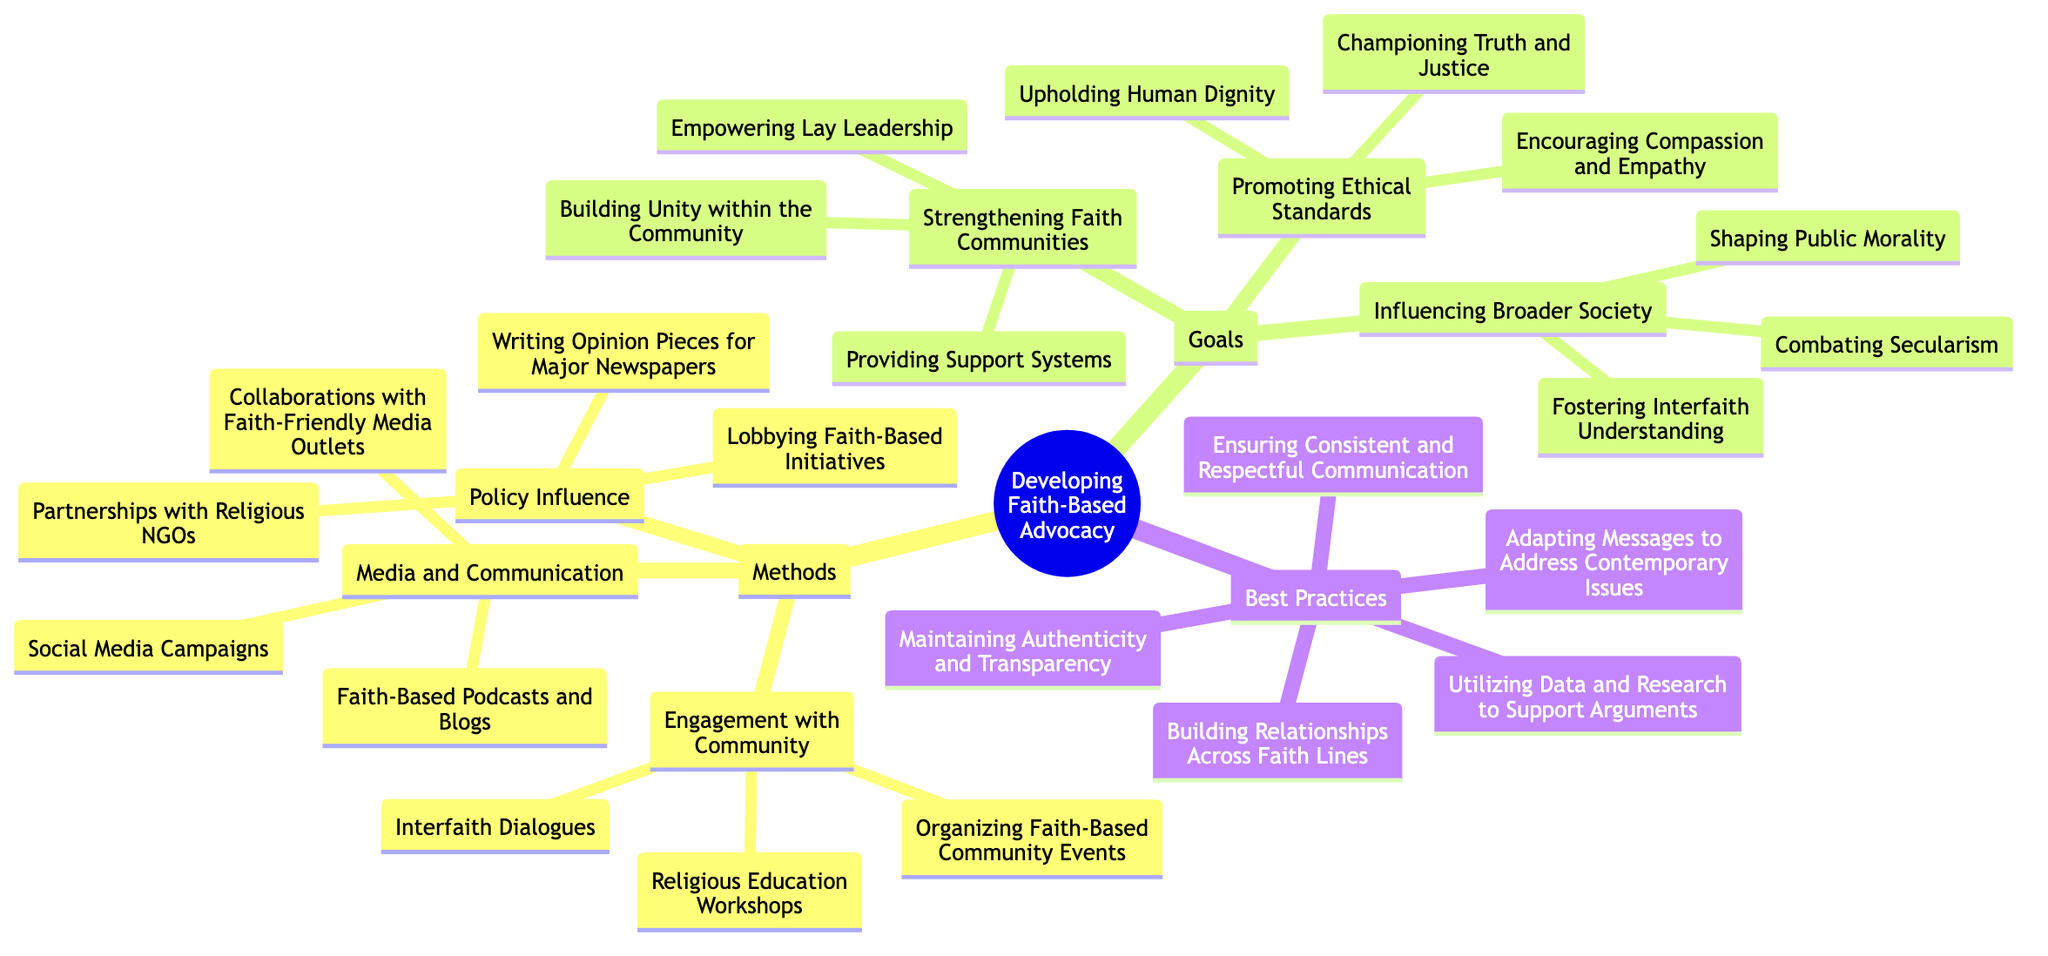What are the three methods listed under "Media and Communication"? The diagram shows that under "Media and Communication," there are three listed methods: "Social Media Campaigns," "Faith-Based Podcasts and Blogs," and "Collaborations with Faith-Friendly Media Outlets."
Answer: Social Media Campaigns, Faith-Based Podcasts and Blogs, Collaborations with Faith-Friendly Media Outlets How many nodes are there under the "Goals" section? The "Goals" section consists of three main nodes: "Promoting Ethical Standards," "Strengthening Faith Communities," and "Influencing Broader Society." Therefore, the total number of nodes in the "Goals" section is three.
Answer: 3 Which best practice emphasizes communication? The best practice explicitly mentioning communication is "Ensuring Consistent and Respectful Communication," which highlights the importance of maintaining quality communication in advocacy.
Answer: Ensuring Consistent and Respectful Communication What is one goal related to creating a supportive environment within faith communities? The goal that focuses on creating a supportive environment within faith communities is "Providing Support Systems," as it emphasizes the importance of support within the community.
Answer: Providing Support Systems What is the main theme of the "Engagement with Community" methods? The primary focus of the "Engagement with Community" methods is to foster interaction and participation within the community through various initiatives like events and dialogues.
Answer: Fostering interaction and participation How many total methods are there in the "Methods" section? The “Methods” section comprises three categories: "Engagement with Community," "Media and Communication," and "Policy Influence," each containing multiple specific methods. In total, there are nine methods listed across these categories.
Answer: 9 What is the purpose of "Lobbying Faith-Based Initiatives" in the context of policy influence? "Lobbying Faith-Based Initiatives" aims to actively advocate for specific policies that reflect faith-based values and principles, thus influencing governmental or legislative actions.
Answer: Actively advocate for policies Which method under “Engagement with Community” focuses on learning? "Religious Education Workshops" is the method that primarily focuses on learning within the community by providing educational opportunities related to faith.
Answer: Religious Education Workshops How does "Combating Secularism" relate to the goals of faith-based advocacy? "Combating Secularism" aims to challenge secular views in society, aligning with the goal of "Influencing Broader Society" by promoting faith-based perspectives on public morality and ethics.
Answer: Challenge secular views 